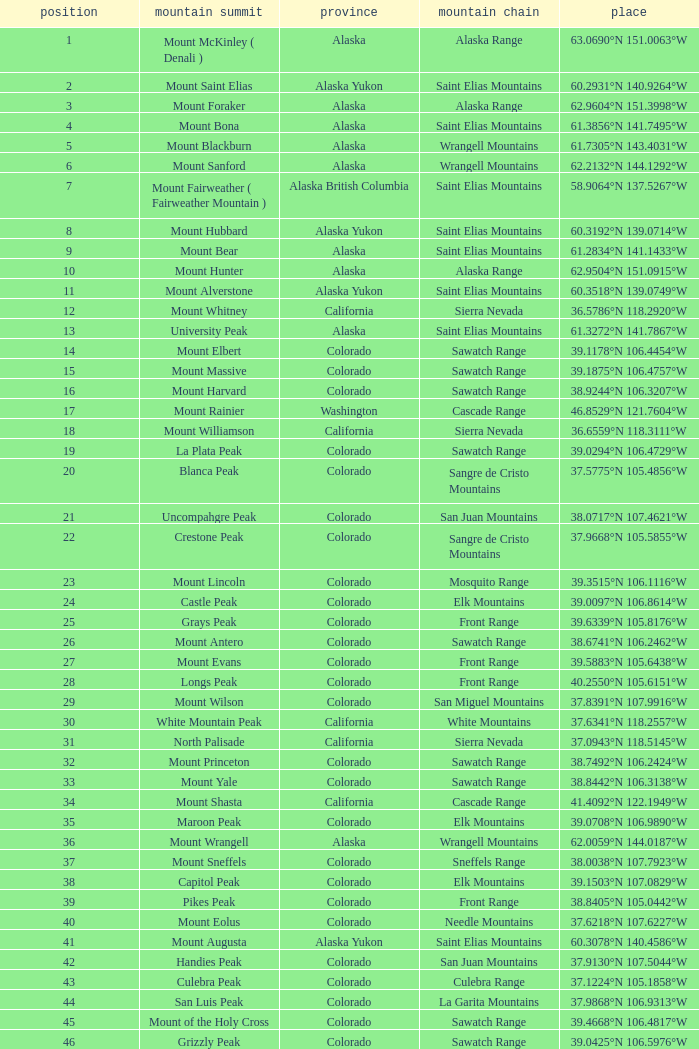What is the rank when the state is colorado and the location is 37.7859°n 107.7039°w? 83.0. 